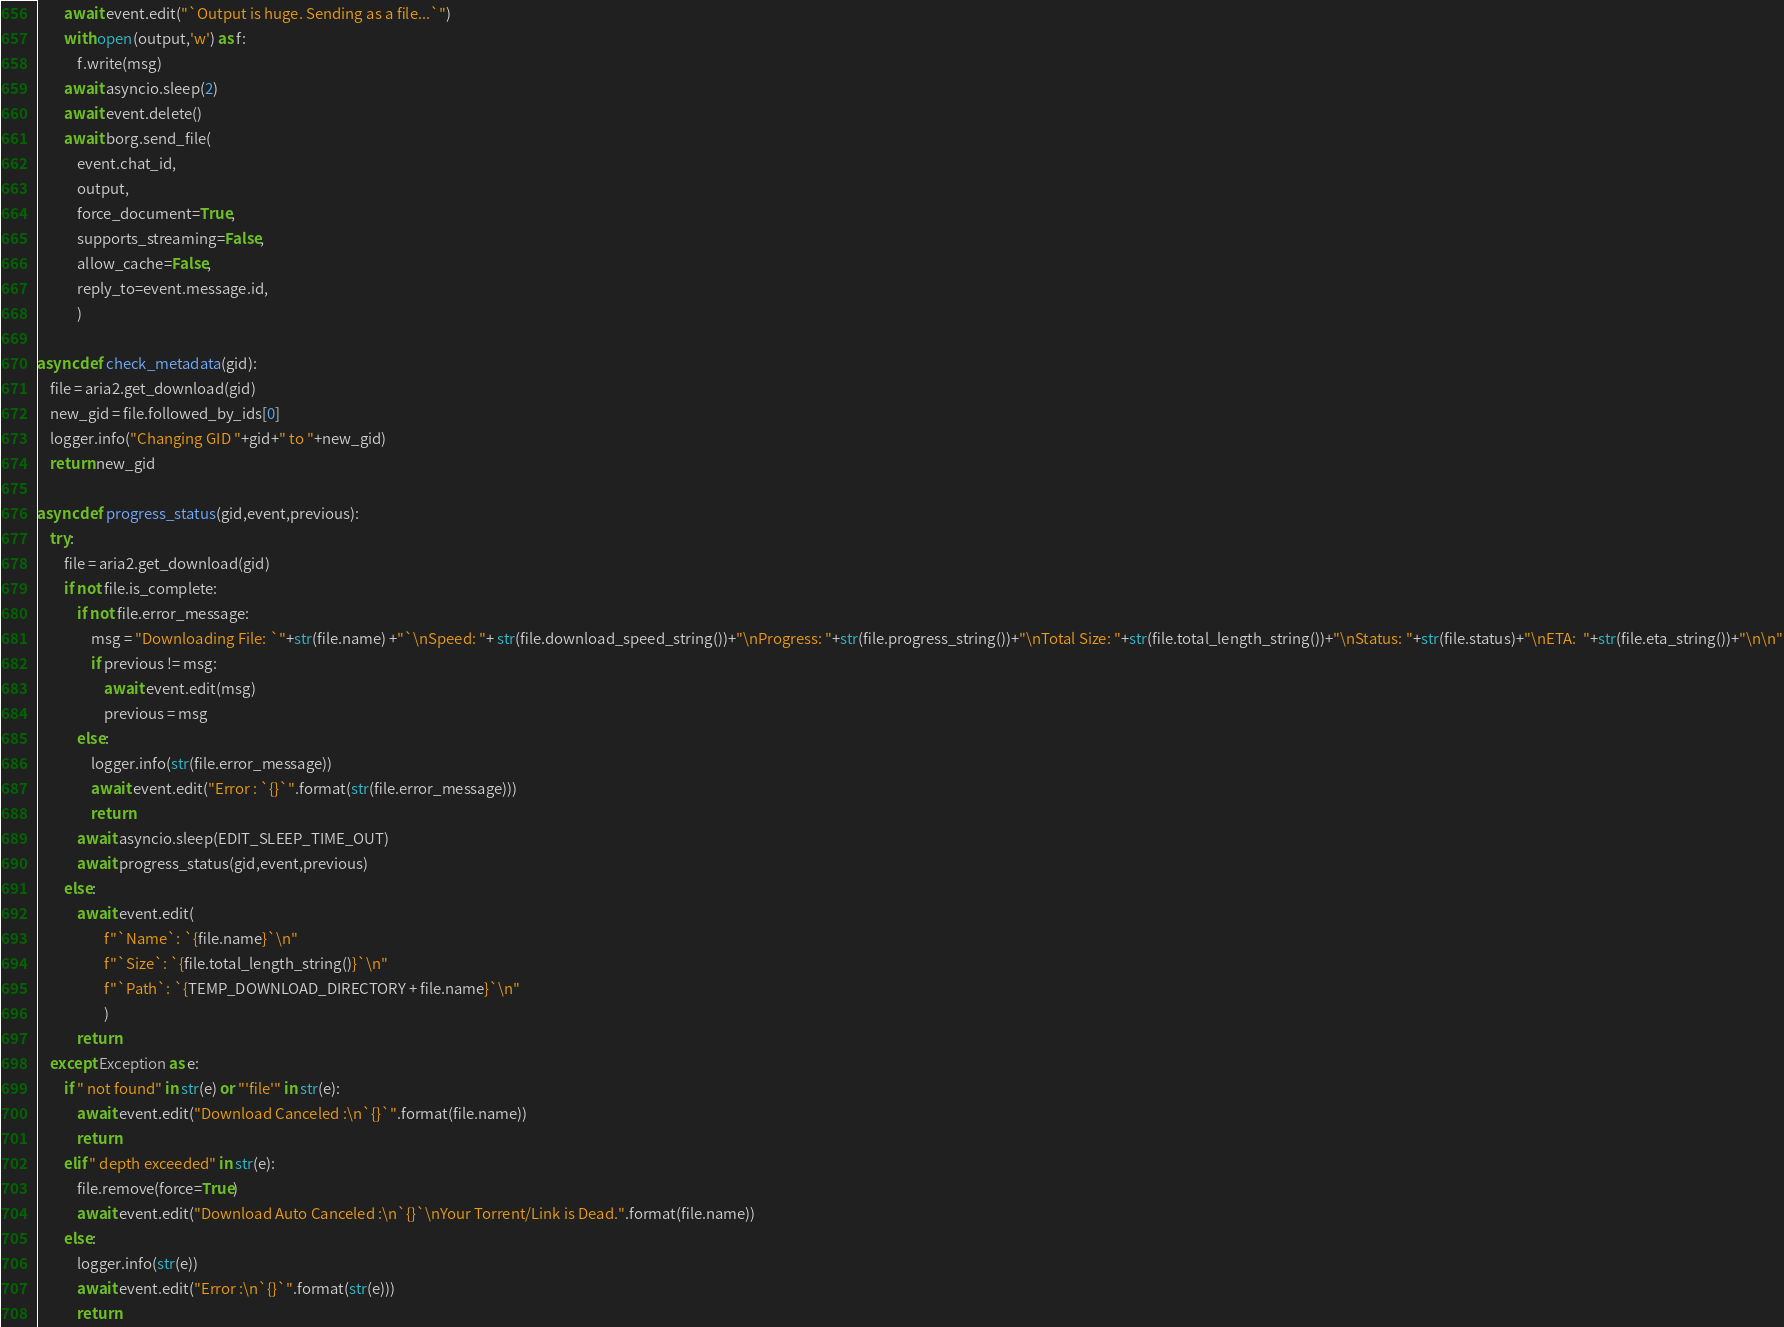<code> <loc_0><loc_0><loc_500><loc_500><_Python_>		await event.edit("`Output is huge. Sending as a file...`")
		with open(output,'w') as f:
			f.write(msg)
		await asyncio.sleep(2)	
		await event.delete()	
		await borg.send_file(
			event.chat_id,
			output,
			force_document=True,
			supports_streaming=False,
			allow_cache=False,
			reply_to=event.message.id,
			)				

async def check_metadata(gid):
	file = aria2.get_download(gid)
	new_gid = file.followed_by_ids[0]
	logger.info("Changing GID "+gid+" to "+new_gid)
	return new_gid	

async def progress_status(gid,event,previous):
	try:
		file = aria2.get_download(gid)
		if not file.is_complete:
			if not file.error_message:
				msg = "Downloading File: `"+str(file.name) +"`\nSpeed: "+ str(file.download_speed_string())+"\nProgress: "+str(file.progress_string())+"\nTotal Size: "+str(file.total_length_string())+"\nStatus: "+str(file.status)+"\nETA:  "+str(file.eta_string())+"\n\n"
				if previous != msg:
					await event.edit(msg)
					previous = msg
			else:
				logger.info(str(file.error_message))
				await event.edit("Error : `{}`".format(str(file.error_message)))		
				return
			await asyncio.sleep(EDIT_SLEEP_TIME_OUT)	
			await progress_status(gid,event,previous)
		else:
			await event.edit(
                    f"`Name`: `{file.name}`\n"
                    f"`Size`: `{file.total_length_string()}`\n"
                    f"`Path`: `{TEMP_DOWNLOAD_DIRECTORY + file.name}`\n"
                    )
			return
	except Exception as e:
		if " not found" in str(e) or "'file'" in str(e):
			await event.edit("Download Canceled :\n`{}`".format(file.name))
			return
		elif " depth exceeded" in str(e):
			file.remove(force=True)
			await event.edit("Download Auto Canceled :\n`{}`\nYour Torrent/Link is Dead.".format(file.name))
		else:
			logger.info(str(e))
			await event.edit("Error :\n`{}`".format(str(e)))
			return
</code> 